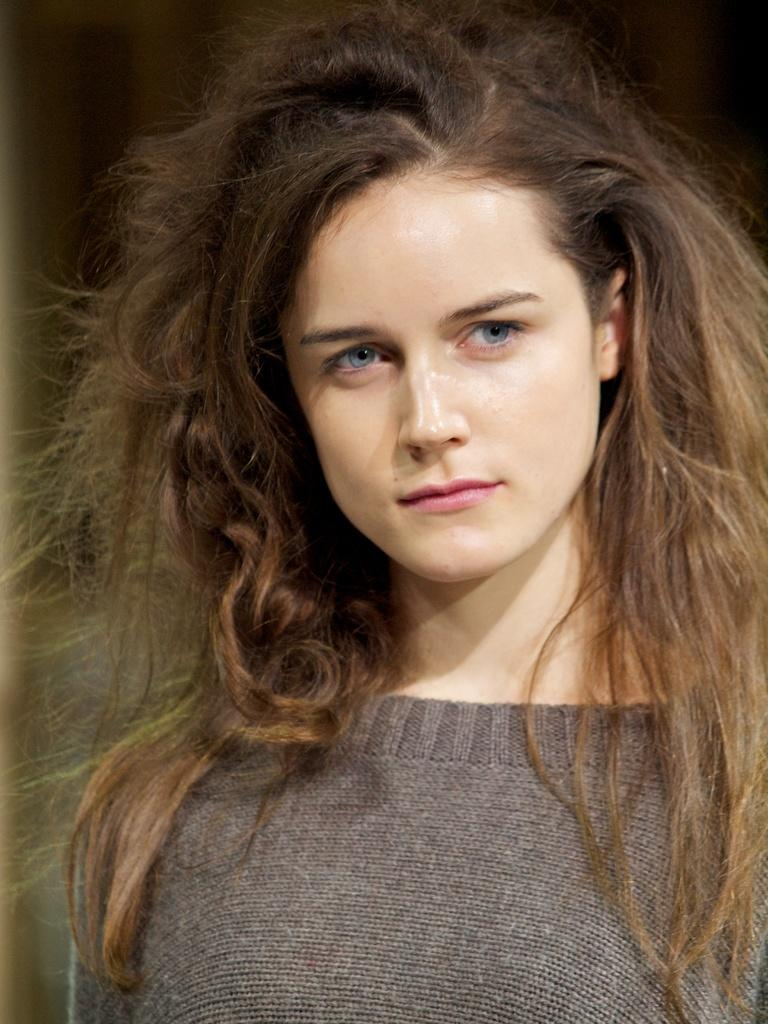Who is the main subject in the image? There is a woman in the image. What is the woman wearing? The woman is wearing a t-shirt. In which direction is the woman looking? The woman is looking to the right side. Can you describe the background of the image? The background of the image is blurred. How many babies are visible in the image? There are no babies present in the image; it features a woman looking to the right side. What type of prose is the woman reading in the image? There is no indication in the image that the woman is reading any prose. 